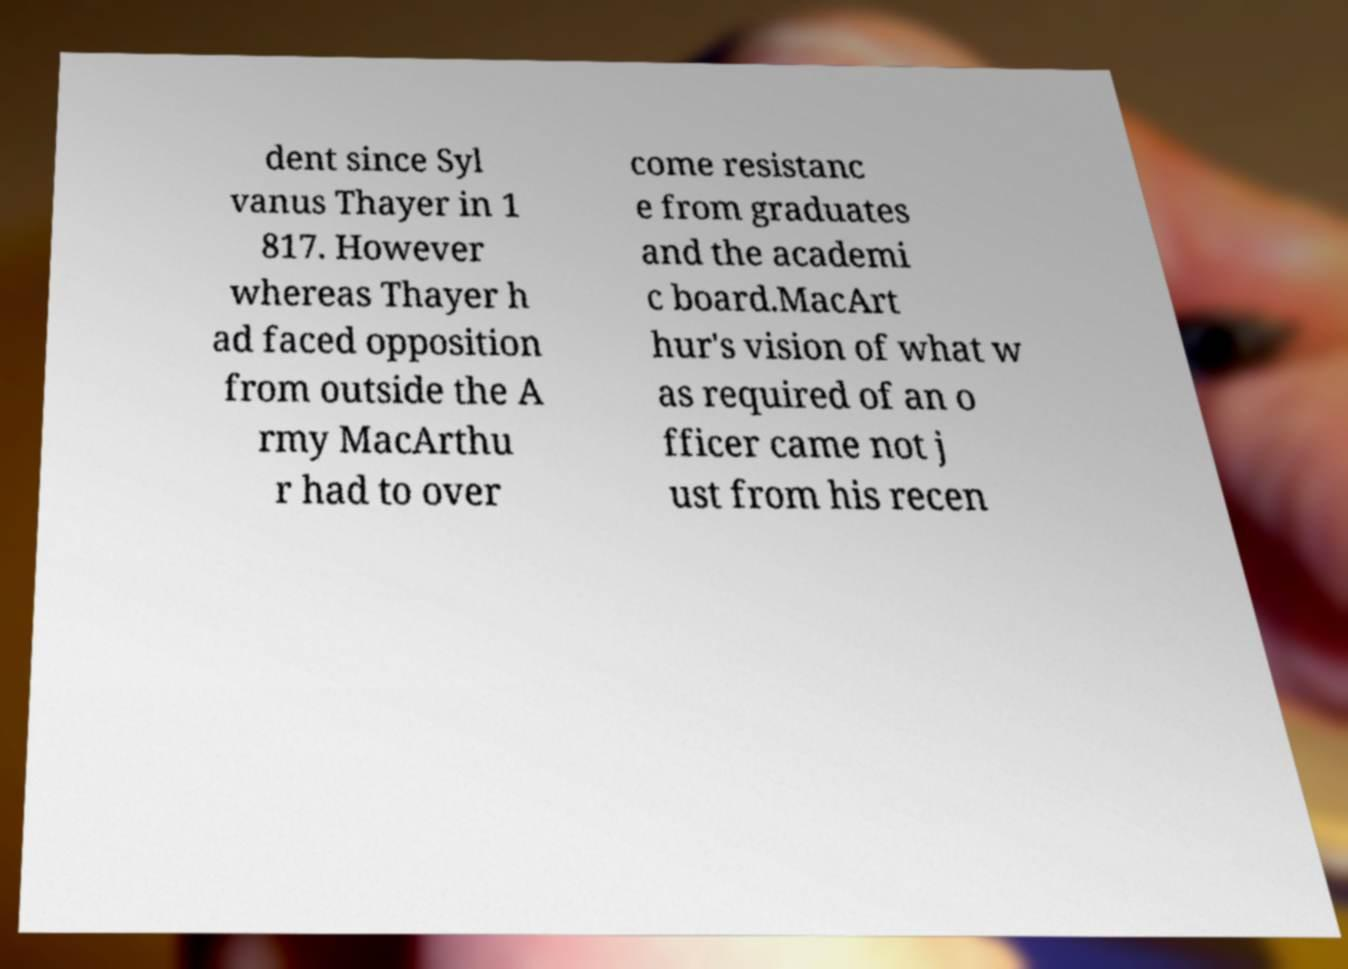I need the written content from this picture converted into text. Can you do that? dent since Syl vanus Thayer in 1 817. However whereas Thayer h ad faced opposition from outside the A rmy MacArthu r had to over come resistanc e from graduates and the academi c board.MacArt hur's vision of what w as required of an o fficer came not j ust from his recen 